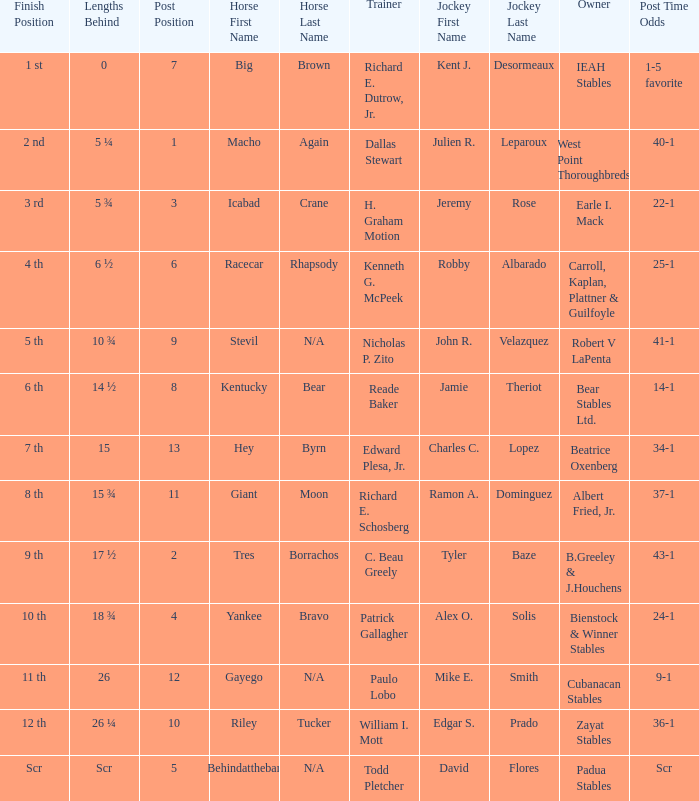Who is the owner of Icabad Crane? Earle I. Mack. 